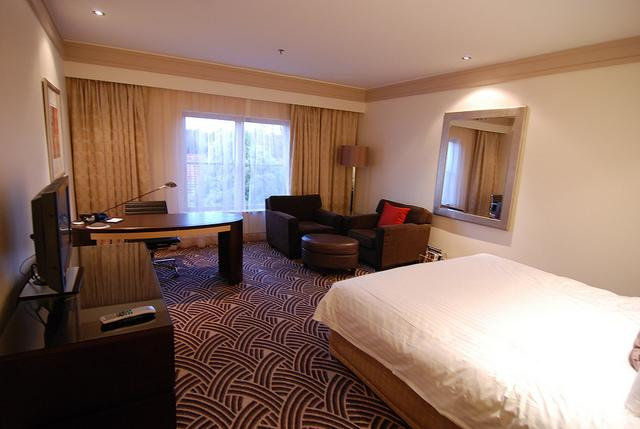The pillow on the couch is the same color as what?

Choices:
A) lemon
B) lime
C) tomato
D) orange tomato 